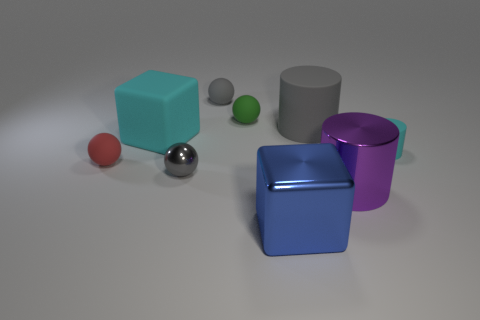Subtract 1 spheres. How many spheres are left? 3 Add 1 large cyan objects. How many objects exist? 10 Subtract all cylinders. How many objects are left? 6 Subtract 0 brown cylinders. How many objects are left? 9 Subtract all cyan things. Subtract all rubber spheres. How many objects are left? 4 Add 9 red matte spheres. How many red matte spheres are left? 10 Add 3 tiny gray shiny balls. How many tiny gray shiny balls exist? 4 